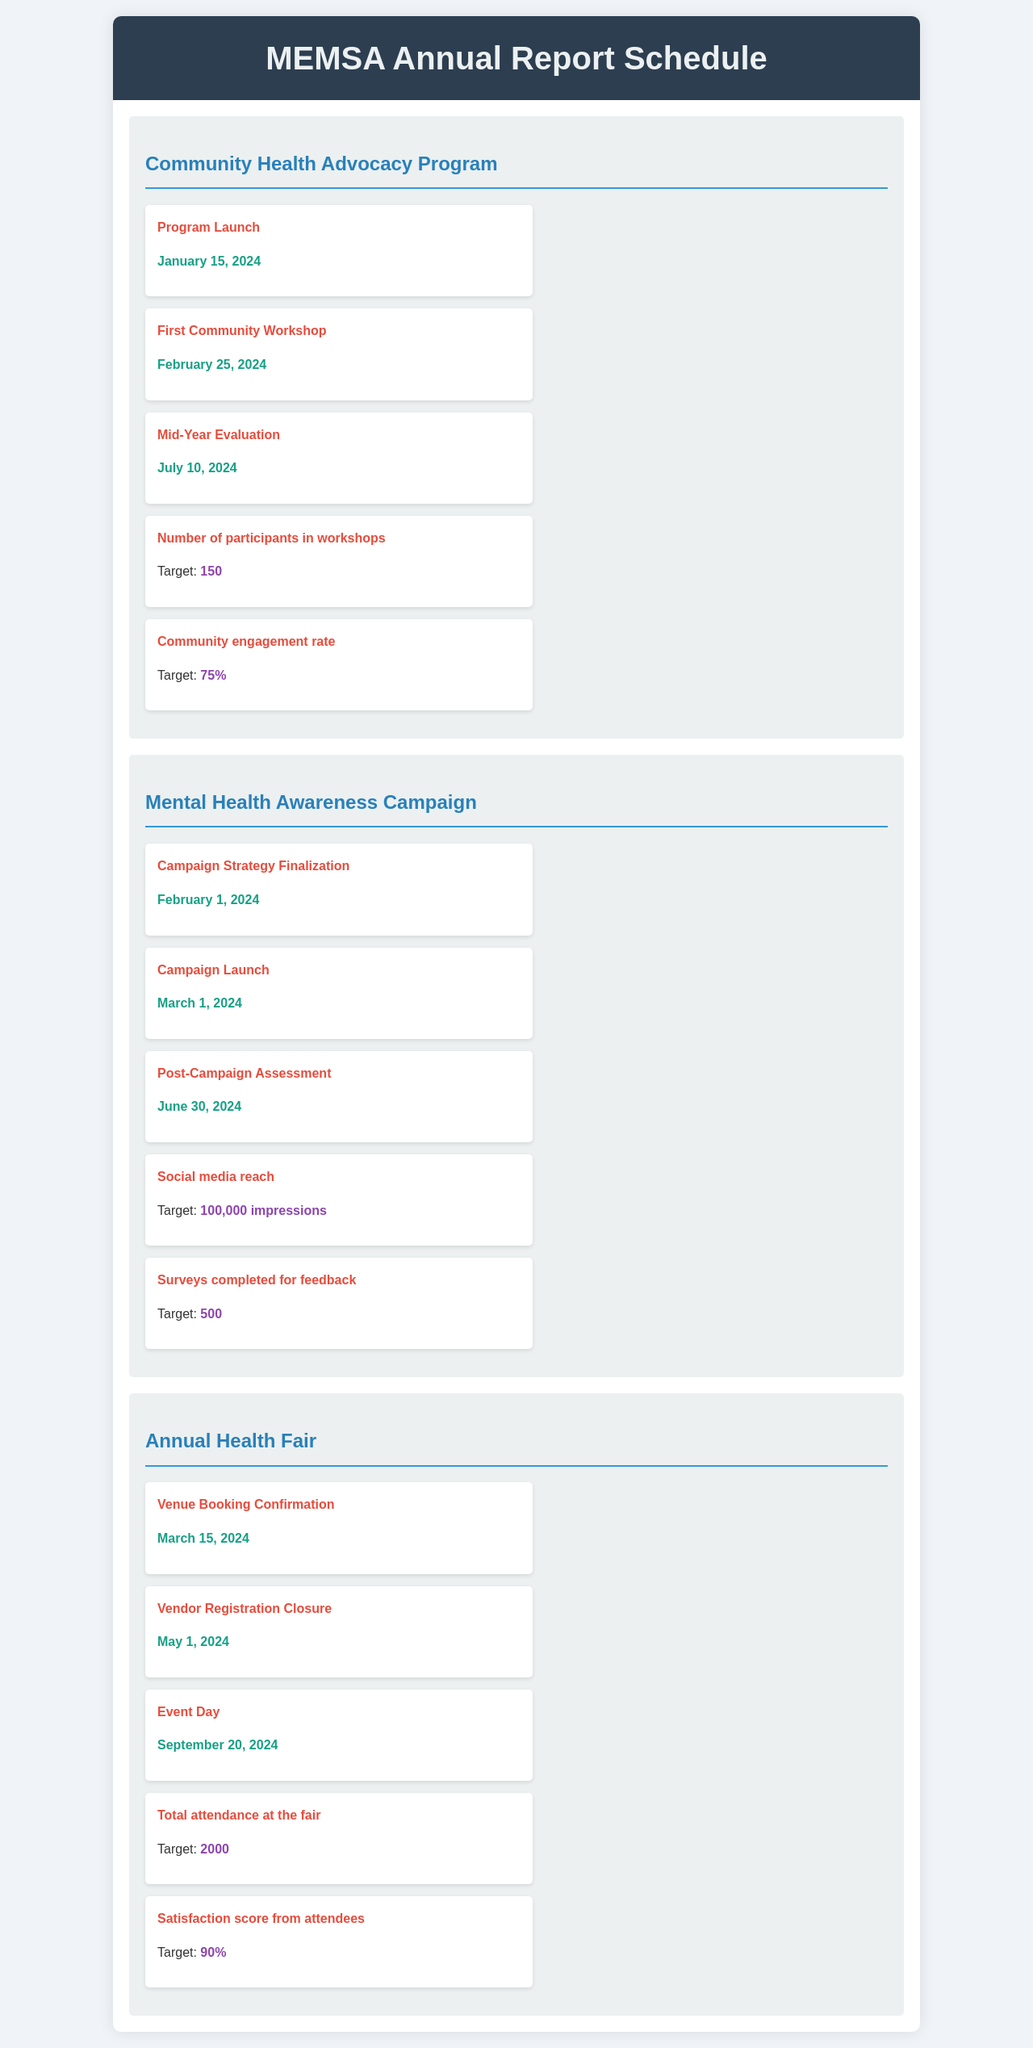What is the date of the Program Launch for the Community Health Advocacy Program? The Program Launch is scheduled for January 15, 2024.
Answer: January 15, 2024 What is the target number of participants in the workshops for the Community Health Advocacy Program? The target number of participants is stated as 150.
Answer: 150 When is the Campaign Launch for the Mental Health Awareness Campaign? The Campaign Launch is on March 1, 2024.
Answer: March 1, 2024 What is the target for social media reach in the Mental Health Awareness Campaign? The target for social media reach is specified as 100,000 impressions.
Answer: 100,000 impressions What is the date of the Event Day for the Annual Health Fair? The Event Day is set for September 20, 2024.
Answer: September 20, 2024 What is the satisfaction score target from attendees at the Annual Health Fair? The satisfaction score target from attendees is noted as 90%.
Answer: 90% How many surveys are to be completed for feedback in the Mental Health Awareness Campaign? The document indicates a target of 500 surveys to be completed.
Answer: 500 What is the milestone before the Mid-Year Evaluation for the Community Health Advocacy Program? The milestone before the Mid-Year Evaluation is the First Community Workshop.
Answer: First Community Workshop What is the date for the Post-Campaign Assessment in the Mental Health Awareness Campaign? The Post-Campaign Assessment is scheduled for June 30, 2024.
Answer: June 30, 2024 